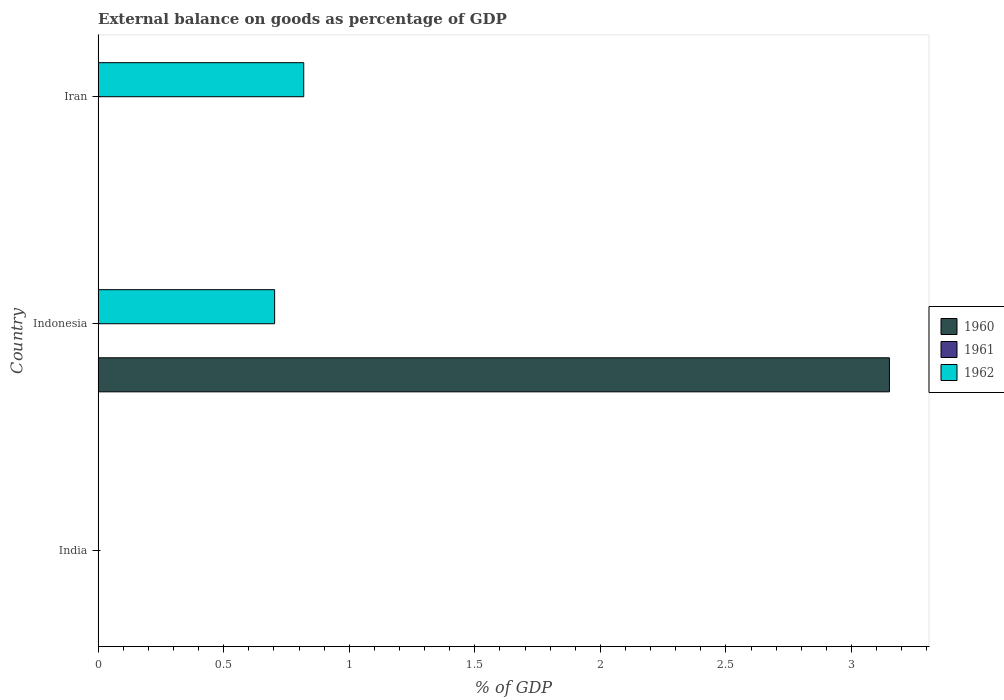How many bars are there on the 3rd tick from the bottom?
Your answer should be very brief. 1. What is the label of the 3rd group of bars from the top?
Ensure brevity in your answer.  India. In how many cases, is the number of bars for a given country not equal to the number of legend labels?
Your answer should be compact. 3. What is the external balance on goods as percentage of GDP in 1960 in Indonesia?
Your response must be concise. 3.15. Across all countries, what is the maximum external balance on goods as percentage of GDP in 1962?
Make the answer very short. 0.82. In which country was the external balance on goods as percentage of GDP in 1960 maximum?
Give a very brief answer. Indonesia. What is the total external balance on goods as percentage of GDP in 1960 in the graph?
Your response must be concise. 3.15. What is the difference between the external balance on goods as percentage of GDP in 1962 in Indonesia and that in Iran?
Ensure brevity in your answer.  -0.12. What is the difference between the external balance on goods as percentage of GDP in 1962 in India and the external balance on goods as percentage of GDP in 1961 in Indonesia?
Provide a short and direct response. 0. What is the difference between the external balance on goods as percentage of GDP in 1962 and external balance on goods as percentage of GDP in 1960 in Indonesia?
Provide a succinct answer. -2.45. What is the ratio of the external balance on goods as percentage of GDP in 1962 in Indonesia to that in Iran?
Offer a very short reply. 0.86. Is the external balance on goods as percentage of GDP in 1962 in Indonesia less than that in Iran?
Your answer should be very brief. Yes. What is the difference between the highest and the lowest external balance on goods as percentage of GDP in 1960?
Keep it short and to the point. 3.15. Is the sum of the external balance on goods as percentage of GDP in 1962 in Indonesia and Iran greater than the maximum external balance on goods as percentage of GDP in 1961 across all countries?
Keep it short and to the point. Yes. Are the values on the major ticks of X-axis written in scientific E-notation?
Provide a succinct answer. No. How many legend labels are there?
Offer a very short reply. 3. What is the title of the graph?
Your answer should be very brief. External balance on goods as percentage of GDP. Does "2003" appear as one of the legend labels in the graph?
Your response must be concise. No. What is the label or title of the X-axis?
Your answer should be very brief. % of GDP. What is the % of GDP in 1960 in Indonesia?
Keep it short and to the point. 3.15. What is the % of GDP in 1961 in Indonesia?
Your response must be concise. 0. What is the % of GDP of 1962 in Indonesia?
Offer a very short reply. 0.7. What is the % of GDP of 1962 in Iran?
Give a very brief answer. 0.82. Across all countries, what is the maximum % of GDP of 1960?
Give a very brief answer. 3.15. Across all countries, what is the maximum % of GDP in 1962?
Offer a terse response. 0.82. Across all countries, what is the minimum % of GDP in 1960?
Your answer should be compact. 0. Across all countries, what is the minimum % of GDP of 1962?
Your answer should be compact. 0. What is the total % of GDP in 1960 in the graph?
Ensure brevity in your answer.  3.15. What is the total % of GDP of 1961 in the graph?
Your response must be concise. 0. What is the total % of GDP in 1962 in the graph?
Ensure brevity in your answer.  1.52. What is the difference between the % of GDP of 1962 in Indonesia and that in Iran?
Ensure brevity in your answer.  -0.12. What is the difference between the % of GDP in 1960 in Indonesia and the % of GDP in 1962 in Iran?
Give a very brief answer. 2.33. What is the average % of GDP of 1960 per country?
Offer a very short reply. 1.05. What is the average % of GDP of 1962 per country?
Your answer should be very brief. 0.51. What is the difference between the % of GDP of 1960 and % of GDP of 1962 in Indonesia?
Your response must be concise. 2.45. What is the ratio of the % of GDP in 1962 in Indonesia to that in Iran?
Provide a short and direct response. 0.86. What is the difference between the highest and the lowest % of GDP of 1960?
Provide a short and direct response. 3.15. What is the difference between the highest and the lowest % of GDP in 1962?
Offer a very short reply. 0.82. 